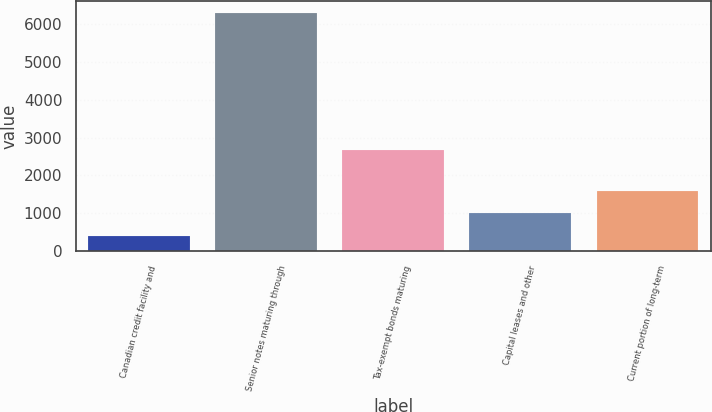<chart> <loc_0><loc_0><loc_500><loc_500><bar_chart><fcel>Canadian credit facility and<fcel>Senior notes maturing through<fcel>Tax-exempt bonds maturing<fcel>Capital leases and other<fcel>Current portion of long-term<nl><fcel>414<fcel>6287<fcel>2664<fcel>1001.3<fcel>1588.6<nl></chart> 